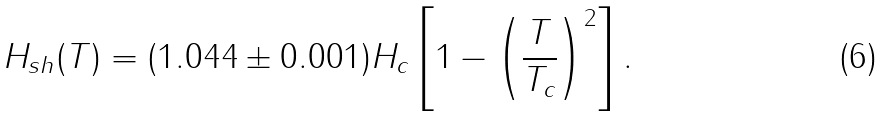Convert formula to latex. <formula><loc_0><loc_0><loc_500><loc_500>H _ { s h } ( T ) = ( 1 . 0 4 4 \pm 0 . 0 0 1 ) H _ { c } \left [ 1 - \left ( \frac { T } { T _ { c } } \right ) ^ { 2 } \right ] .</formula> 